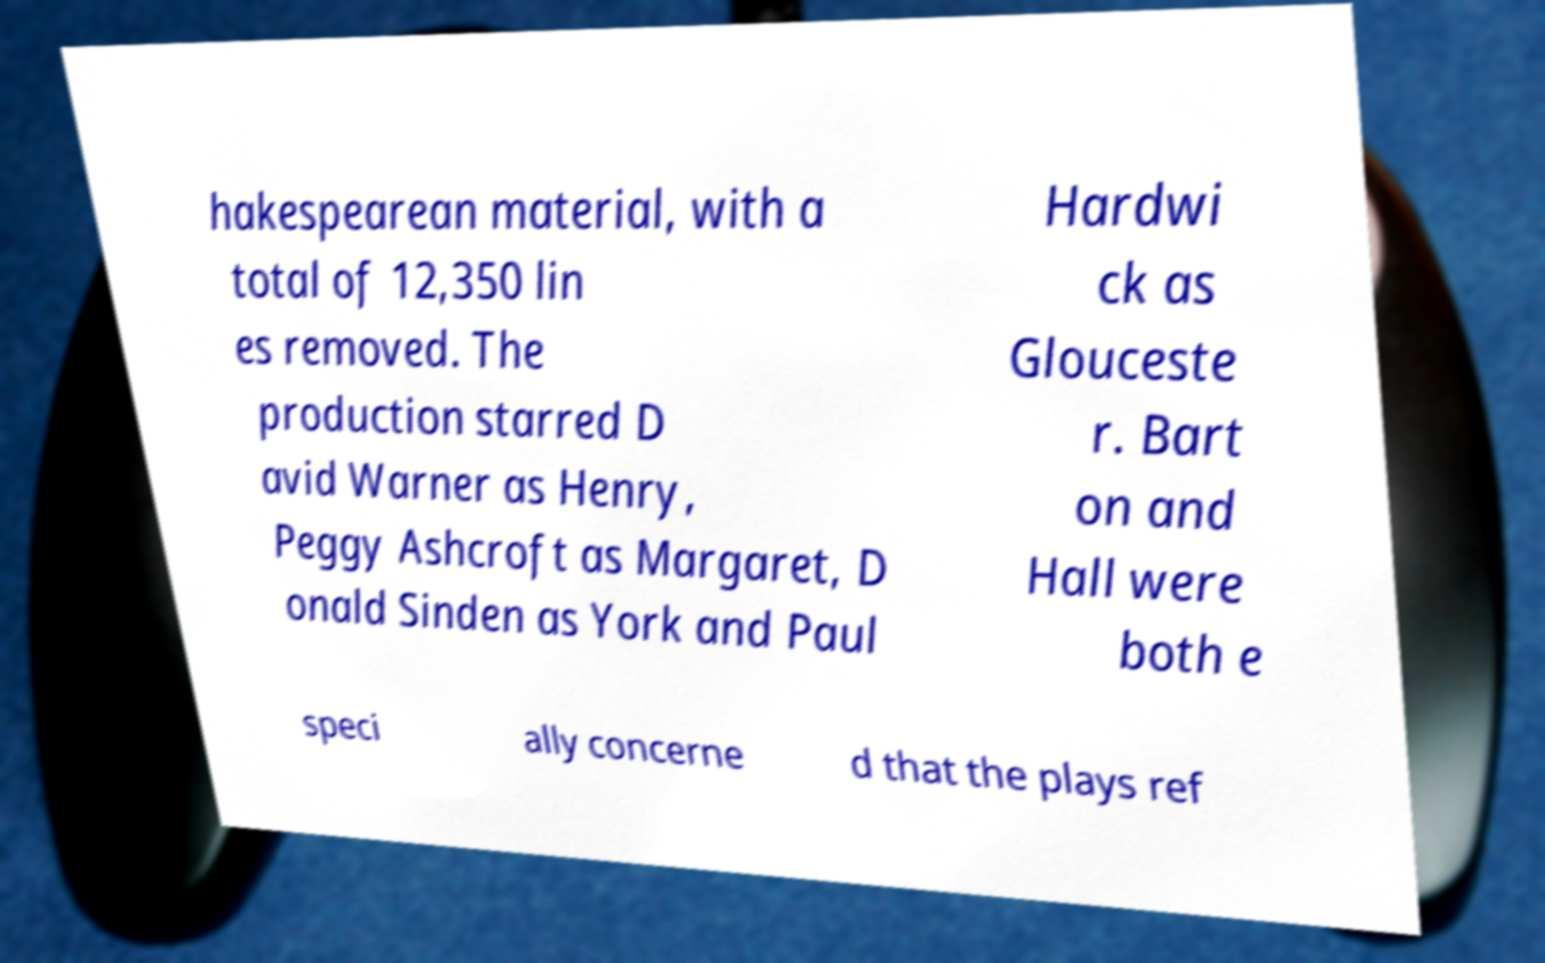Could you extract and type out the text from this image? hakespearean material, with a total of 12,350 lin es removed. The production starred D avid Warner as Henry, Peggy Ashcroft as Margaret, D onald Sinden as York and Paul Hardwi ck as Glouceste r. Bart on and Hall were both e speci ally concerne d that the plays ref 